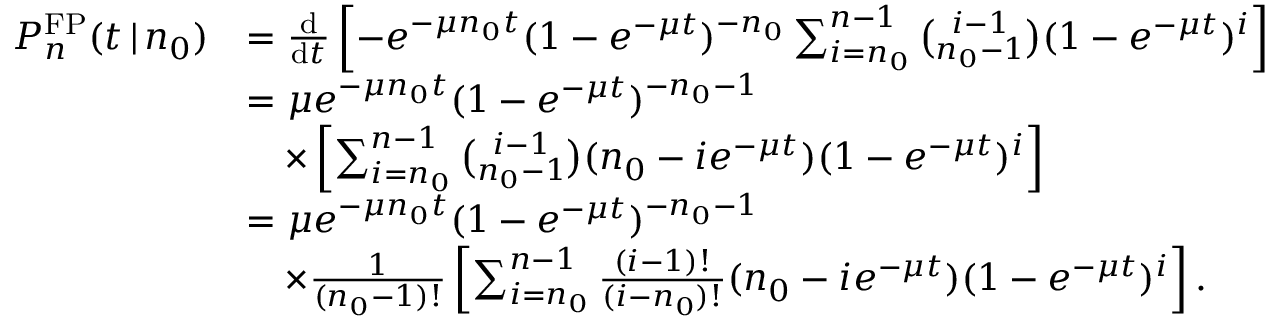Convert formula to latex. <formula><loc_0><loc_0><loc_500><loc_500>\begin{array} { r l } { P _ { n } ^ { F P } ( t \, | \, n _ { 0 } ) } & { = \frac { d } { d t } \left [ - e ^ { - \mu n _ { 0 } t } ( 1 - e ^ { - \mu t } ) ^ { - n _ { 0 } } \sum _ { i = n _ { 0 } } ^ { n - 1 } { \binom { i - 1 } { n _ { 0 } - 1 } } ( 1 - e ^ { - \mu t } ) ^ { i } \right ] } \\ & { = \mu e ^ { - \mu n _ { 0 } t } ( 1 - e ^ { - \mu t } ) ^ { - n _ { 0 } - 1 } } \\ & { \quad \times \left [ \sum _ { i = n _ { 0 } } ^ { n - 1 } { \binom { i - 1 } { n _ { 0 } - 1 } } ( n _ { 0 } - i e ^ { - \mu t } ) ( 1 - e ^ { - \mu t } ) ^ { i } \right ] } \\ & { = \mu e ^ { - \mu n _ { 0 } t } ( 1 - e ^ { - \mu t } ) ^ { - n _ { 0 } - 1 } } \\ & { \quad \times \frac { 1 } { ( n _ { 0 } - 1 ) ! } \left [ \sum _ { i = n _ { 0 } } ^ { n - 1 } \frac { ( i - 1 ) ! } { ( i - n _ { 0 } ) ! } ( n _ { 0 } - i e ^ { - \mu t } ) ( 1 - e ^ { - \mu t } ) ^ { i } \right ] . } \end{array}</formula> 